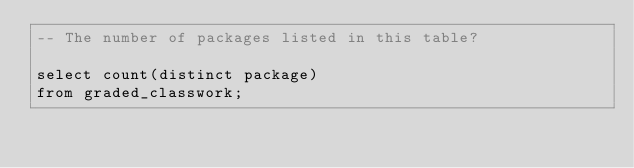Convert code to text. <code><loc_0><loc_0><loc_500><loc_500><_SQL_>-- The number of packages listed in this table?

select count(distinct package)
from graded_classwork;</code> 